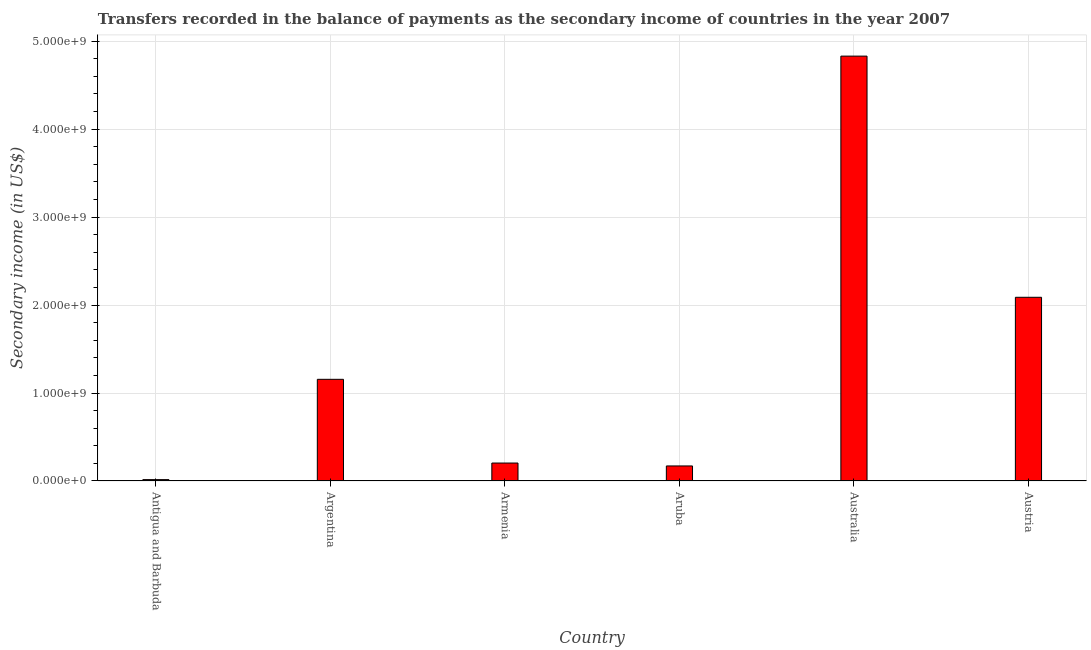Does the graph contain any zero values?
Keep it short and to the point. No. What is the title of the graph?
Provide a short and direct response. Transfers recorded in the balance of payments as the secondary income of countries in the year 2007. What is the label or title of the X-axis?
Ensure brevity in your answer.  Country. What is the label or title of the Y-axis?
Provide a short and direct response. Secondary income (in US$). What is the amount of secondary income in Antigua and Barbuda?
Your response must be concise. 1.56e+07. Across all countries, what is the maximum amount of secondary income?
Make the answer very short. 4.83e+09. Across all countries, what is the minimum amount of secondary income?
Your answer should be very brief. 1.56e+07. In which country was the amount of secondary income maximum?
Your response must be concise. Australia. In which country was the amount of secondary income minimum?
Your answer should be very brief. Antigua and Barbuda. What is the sum of the amount of secondary income?
Ensure brevity in your answer.  8.47e+09. What is the difference between the amount of secondary income in Argentina and Austria?
Provide a short and direct response. -9.33e+08. What is the average amount of secondary income per country?
Your answer should be compact. 1.41e+09. What is the median amount of secondary income?
Your answer should be very brief. 6.80e+08. In how many countries, is the amount of secondary income greater than 1600000000 US$?
Ensure brevity in your answer.  2. What is the ratio of the amount of secondary income in Australia to that in Austria?
Your response must be concise. 2.31. Is the amount of secondary income in Australia less than that in Austria?
Your answer should be very brief. No. Is the difference between the amount of secondary income in Aruba and Australia greater than the difference between any two countries?
Give a very brief answer. No. What is the difference between the highest and the second highest amount of secondary income?
Your answer should be compact. 2.74e+09. What is the difference between the highest and the lowest amount of secondary income?
Make the answer very short. 4.81e+09. Are all the bars in the graph horizontal?
Keep it short and to the point. No. What is the difference between two consecutive major ticks on the Y-axis?
Provide a short and direct response. 1.00e+09. Are the values on the major ticks of Y-axis written in scientific E-notation?
Your answer should be compact. Yes. What is the Secondary income (in US$) of Antigua and Barbuda?
Keep it short and to the point. 1.56e+07. What is the Secondary income (in US$) of Argentina?
Keep it short and to the point. 1.16e+09. What is the Secondary income (in US$) in Armenia?
Your answer should be compact. 2.04e+08. What is the Secondary income (in US$) of Aruba?
Keep it short and to the point. 1.71e+08. What is the Secondary income (in US$) in Australia?
Keep it short and to the point. 4.83e+09. What is the Secondary income (in US$) of Austria?
Your answer should be compact. 2.09e+09. What is the difference between the Secondary income (in US$) in Antigua and Barbuda and Argentina?
Offer a terse response. -1.14e+09. What is the difference between the Secondary income (in US$) in Antigua and Barbuda and Armenia?
Give a very brief answer. -1.89e+08. What is the difference between the Secondary income (in US$) in Antigua and Barbuda and Aruba?
Offer a terse response. -1.55e+08. What is the difference between the Secondary income (in US$) in Antigua and Barbuda and Australia?
Make the answer very short. -4.81e+09. What is the difference between the Secondary income (in US$) in Antigua and Barbuda and Austria?
Keep it short and to the point. -2.07e+09. What is the difference between the Secondary income (in US$) in Argentina and Armenia?
Make the answer very short. 9.52e+08. What is the difference between the Secondary income (in US$) in Argentina and Aruba?
Your response must be concise. 9.85e+08. What is the difference between the Secondary income (in US$) in Argentina and Australia?
Offer a terse response. -3.67e+09. What is the difference between the Secondary income (in US$) in Argentina and Austria?
Your answer should be very brief. -9.33e+08. What is the difference between the Secondary income (in US$) in Armenia and Aruba?
Ensure brevity in your answer.  3.31e+07. What is the difference between the Secondary income (in US$) in Armenia and Australia?
Offer a terse response. -4.63e+09. What is the difference between the Secondary income (in US$) in Armenia and Austria?
Offer a terse response. -1.88e+09. What is the difference between the Secondary income (in US$) in Aruba and Australia?
Provide a short and direct response. -4.66e+09. What is the difference between the Secondary income (in US$) in Aruba and Austria?
Make the answer very short. -1.92e+09. What is the difference between the Secondary income (in US$) in Australia and Austria?
Keep it short and to the point. 2.74e+09. What is the ratio of the Secondary income (in US$) in Antigua and Barbuda to that in Argentina?
Offer a terse response. 0.01. What is the ratio of the Secondary income (in US$) in Antigua and Barbuda to that in Armenia?
Your answer should be very brief. 0.08. What is the ratio of the Secondary income (in US$) in Antigua and Barbuda to that in Aruba?
Your answer should be very brief. 0.09. What is the ratio of the Secondary income (in US$) in Antigua and Barbuda to that in Australia?
Ensure brevity in your answer.  0. What is the ratio of the Secondary income (in US$) in Antigua and Barbuda to that in Austria?
Give a very brief answer. 0.01. What is the ratio of the Secondary income (in US$) in Argentina to that in Armenia?
Your answer should be very brief. 5.66. What is the ratio of the Secondary income (in US$) in Argentina to that in Aruba?
Your answer should be compact. 6.76. What is the ratio of the Secondary income (in US$) in Argentina to that in Australia?
Give a very brief answer. 0.24. What is the ratio of the Secondary income (in US$) in Argentina to that in Austria?
Make the answer very short. 0.55. What is the ratio of the Secondary income (in US$) in Armenia to that in Aruba?
Keep it short and to the point. 1.19. What is the ratio of the Secondary income (in US$) in Armenia to that in Australia?
Offer a terse response. 0.04. What is the ratio of the Secondary income (in US$) in Armenia to that in Austria?
Keep it short and to the point. 0.1. What is the ratio of the Secondary income (in US$) in Aruba to that in Australia?
Give a very brief answer. 0.04. What is the ratio of the Secondary income (in US$) in Aruba to that in Austria?
Your answer should be very brief. 0.08. What is the ratio of the Secondary income (in US$) in Australia to that in Austria?
Provide a succinct answer. 2.31. 